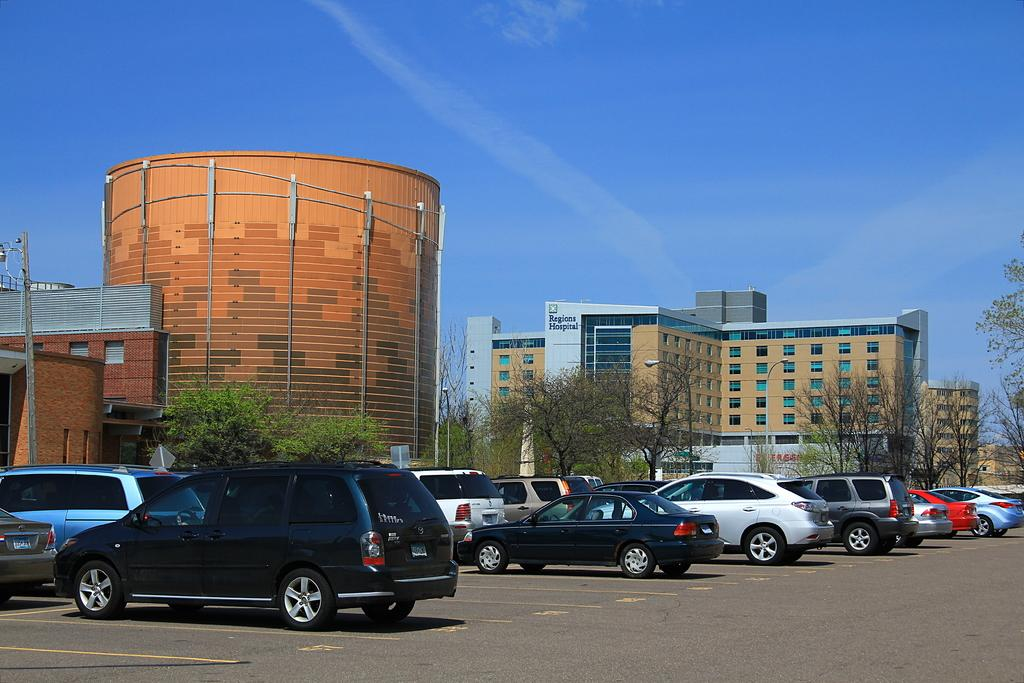What type of structures can be seen in the image? There are buildings in the image. What else can be seen in the image besides buildings? There are poles, trees, vehicles, and the ground visible in the image. What is the background of the image? The sky is visible in the image. What knowledge can be gained from the riddle written on the train in the image? There is no train present in the image, and therefore no riddle can be read or analyzed. 